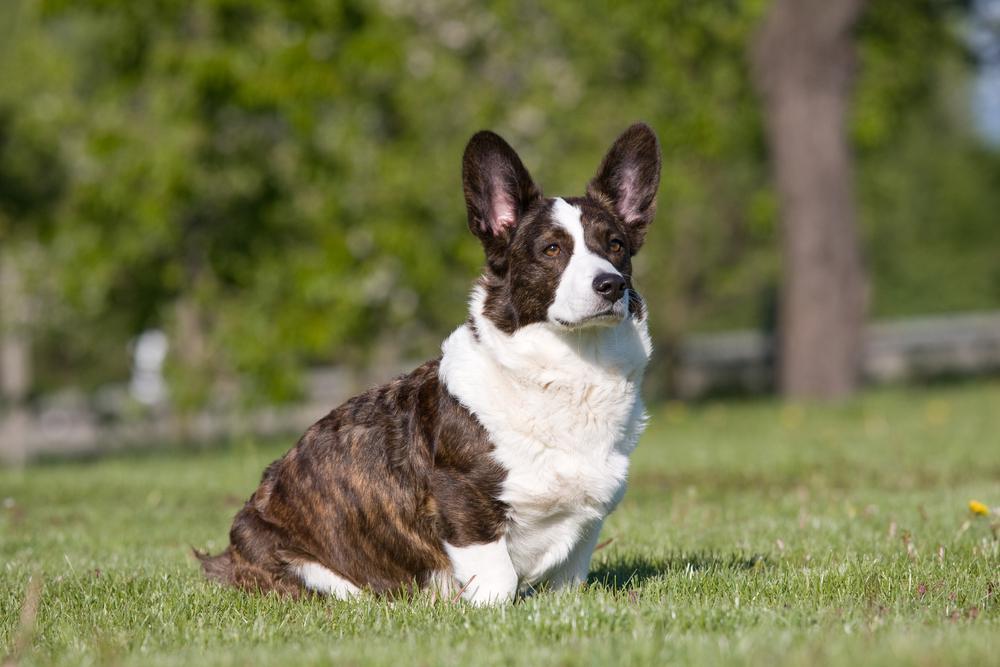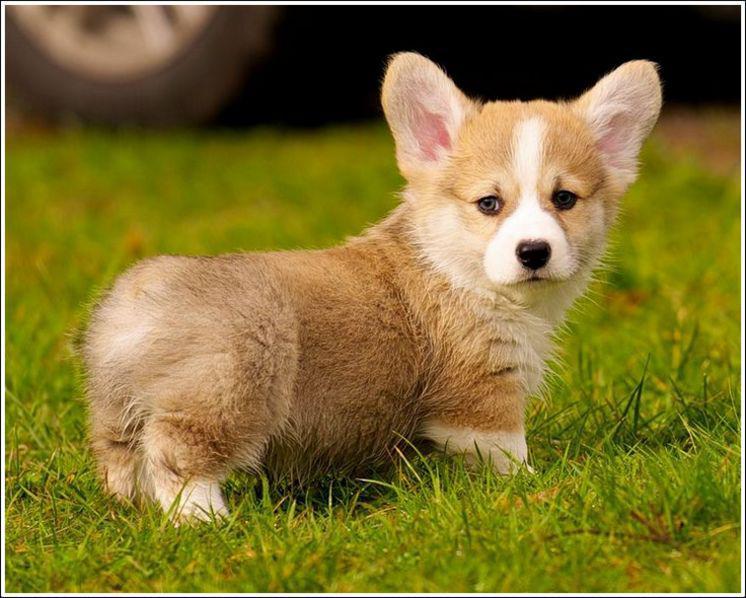The first image is the image on the left, the second image is the image on the right. Assess this claim about the two images: "Each image contains one short-legged corgi, and all dogs are posed on green grass.". Correct or not? Answer yes or no. Yes. The first image is the image on the left, the second image is the image on the right. For the images displayed, is the sentence "A single dog is standing in the grass in the image on the right." factually correct? Answer yes or no. Yes. 